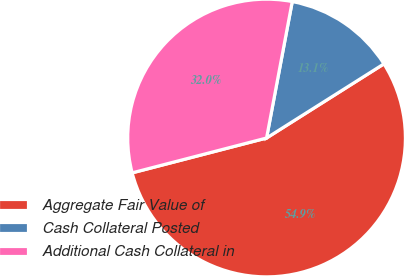Convert chart to OTSL. <chart><loc_0><loc_0><loc_500><loc_500><pie_chart><fcel>Aggregate Fair Value of<fcel>Cash Collateral Posted<fcel>Additional Cash Collateral in<nl><fcel>54.93%<fcel>13.07%<fcel>32.0%<nl></chart> 